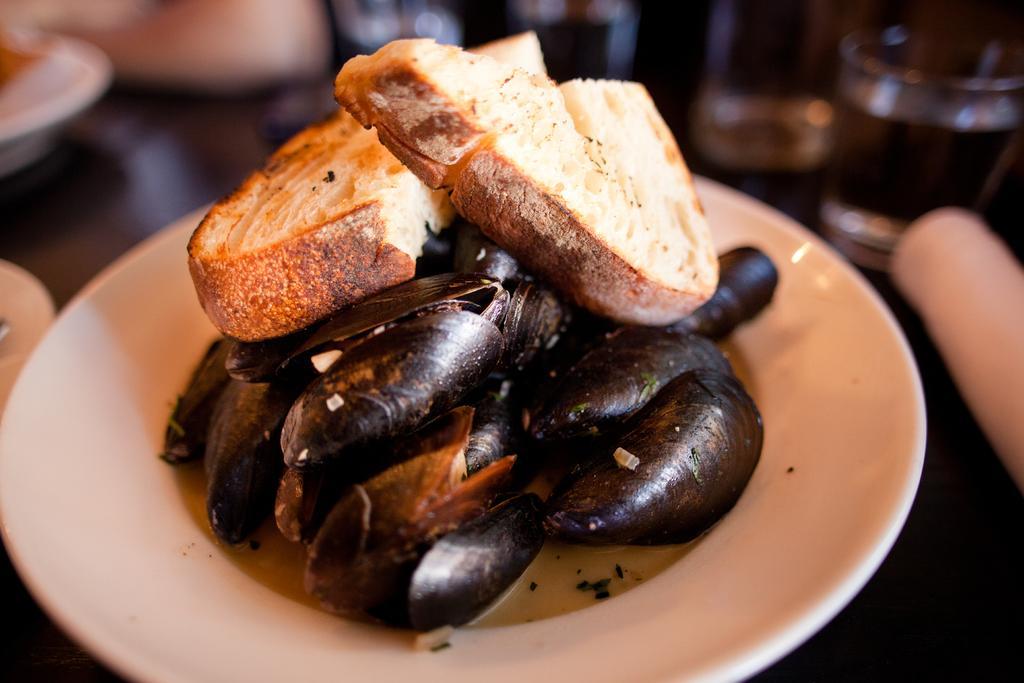How would you summarize this image in a sentence or two? In this image, I can see a plate, which contains mussels and two pieces of bread. In the background, I can see a glass of water and plates are placed on the table. 